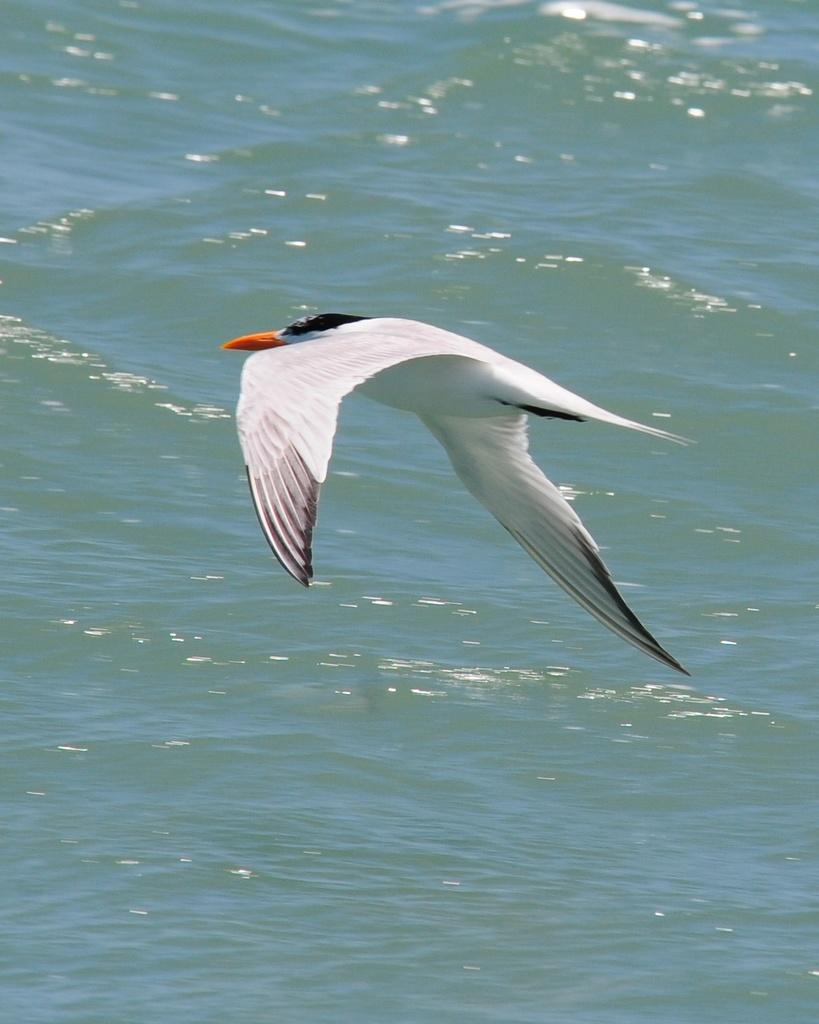What is the main subject of the image? The main subject of the image is a bird flying. Where is the bird located in the image? The bird is in the center of the image. What can be seen in the middle of the image besides the bird? There is water in the middle of the image. What type of arch can be seen in the image? There is no arch present in the image; it features a bird flying and water in the middle. How many women are visible in the image? There are no women visible in the image; it features a bird flying and water in the middle. 